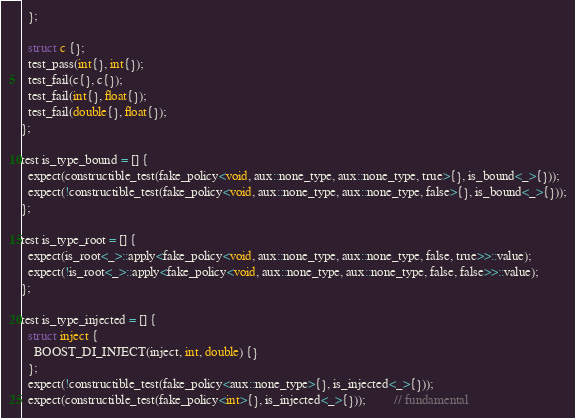<code> <loc_0><loc_0><loc_500><loc_500><_C++_>  };

  struct c {};
  test_pass(int{}, int{});
  test_fail(c{}, c{});
  test_fail(int{}, float{});
  test_fail(double{}, float{});
};

test is_type_bound = [] {
  expect(constructible_test(fake_policy<void, aux::none_type, aux::none_type, true>{}, is_bound<_>{}));
  expect(!constructible_test(fake_policy<void, aux::none_type, aux::none_type, false>{}, is_bound<_>{}));
};

test is_type_root = [] {
  expect(is_root<_>::apply<fake_policy<void, aux::none_type, aux::none_type, false, true>>::value);
  expect(!is_root<_>::apply<fake_policy<void, aux::none_type, aux::none_type, false, false>>::value);
};

test is_type_injected = [] {
  struct inject {
    BOOST_DI_INJECT(inject, int, double) {}
  };
  expect(!constructible_test(fake_policy<aux::none_type>{}, is_injected<_>{}));
  expect(constructible_test(fake_policy<int>{}, is_injected<_>{}));         // fundamental</code> 